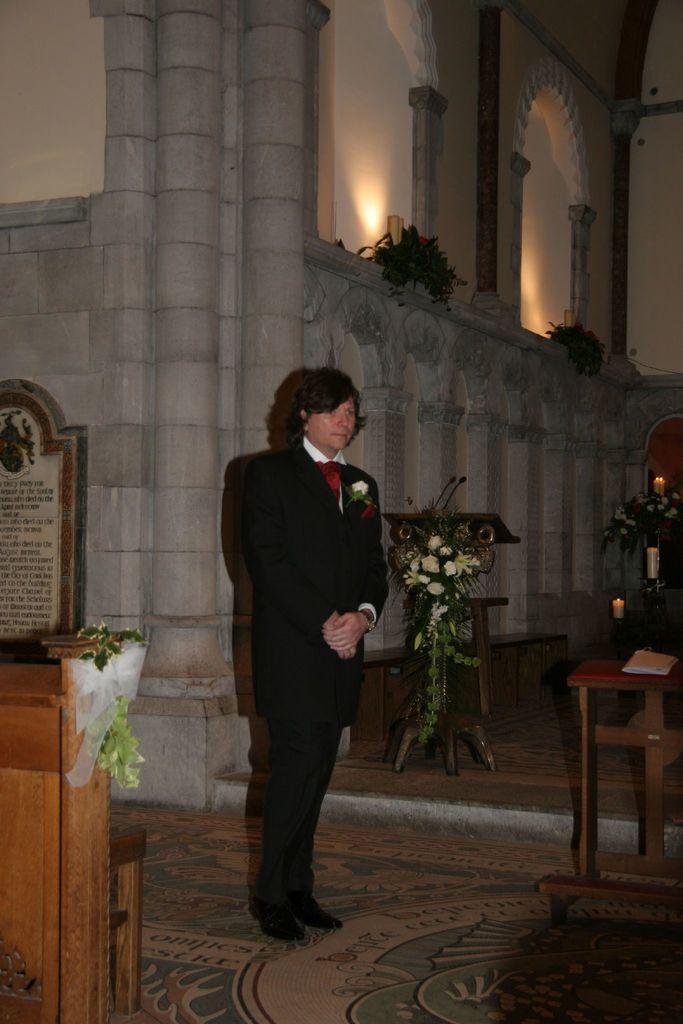Please provide a concise description of this image. In this Picture we can see a man wearing black coat and red tie folding his hand standing toward the camera, beside we can see speech desk and table on which a bush of flowers are seen, Behind we can see the arch design wall and flower bushes, In front we can see the wooden rafter and name plate behind it. 